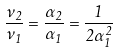Convert formula to latex. <formula><loc_0><loc_0><loc_500><loc_500>\frac { \nu _ { 2 } } { \nu _ { 1 } } = \frac { \alpha _ { 2 } } { \alpha _ { 1 } } = \frac { 1 } { 2 \alpha _ { 1 } ^ { 2 } }</formula> 